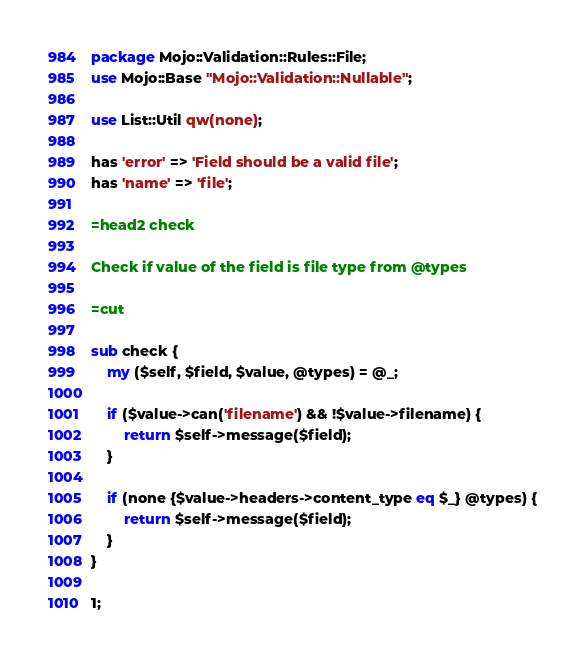Convert code to text. <code><loc_0><loc_0><loc_500><loc_500><_Perl_>package Mojo::Validation::Rules::File;
use Mojo::Base "Mojo::Validation::Nullable";

use List::Util qw(none);

has 'error' => 'Field should be a valid file';
has 'name' => 'file';

=head2 check

Check if value of the field is file type from @types

=cut

sub check {
    my ($self, $field, $value, @types) = @_;

    if ($value->can('filename') && !$value->filename) {
        return $self->message($field);
    }

    if (none {$value->headers->content_type eq $_} @types) {
        return $self->message($field);
    }
}

1;
</code> 